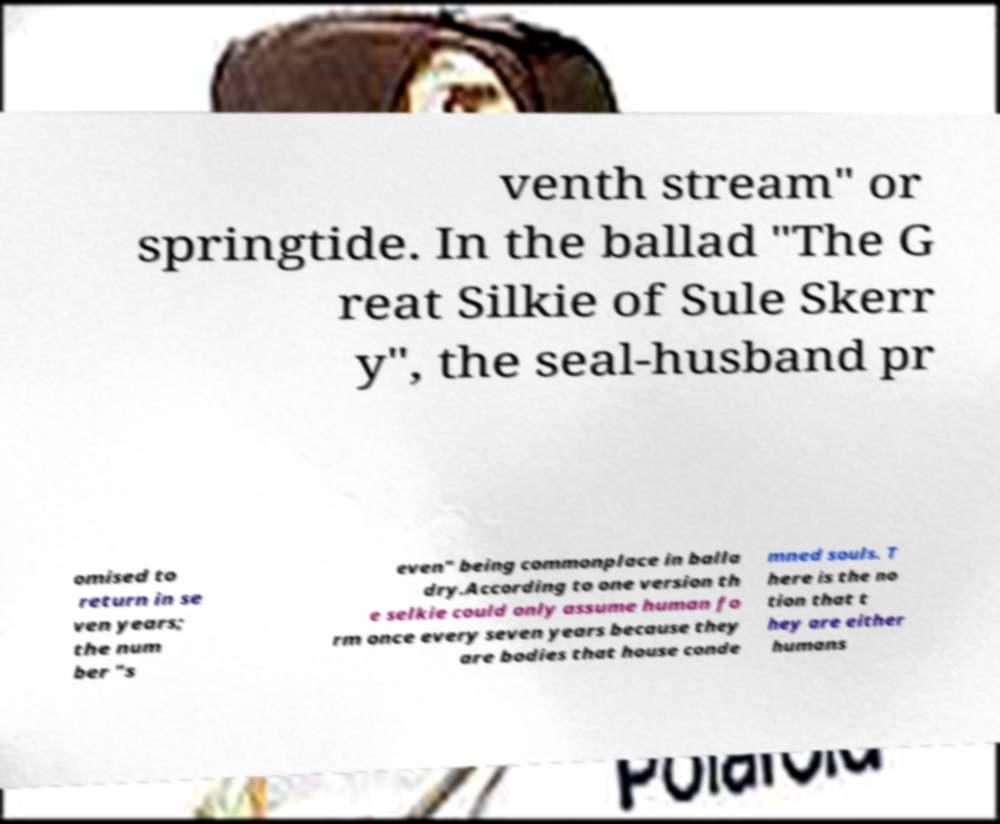There's text embedded in this image that I need extracted. Can you transcribe it verbatim? venth stream" or springtide. In the ballad "The G reat Silkie of Sule Skerr y", the seal-husband pr omised to return in se ven years; the num ber "s even" being commonplace in balla dry.According to one version th e selkie could only assume human fo rm once every seven years because they are bodies that house conde mned souls. T here is the no tion that t hey are either humans 